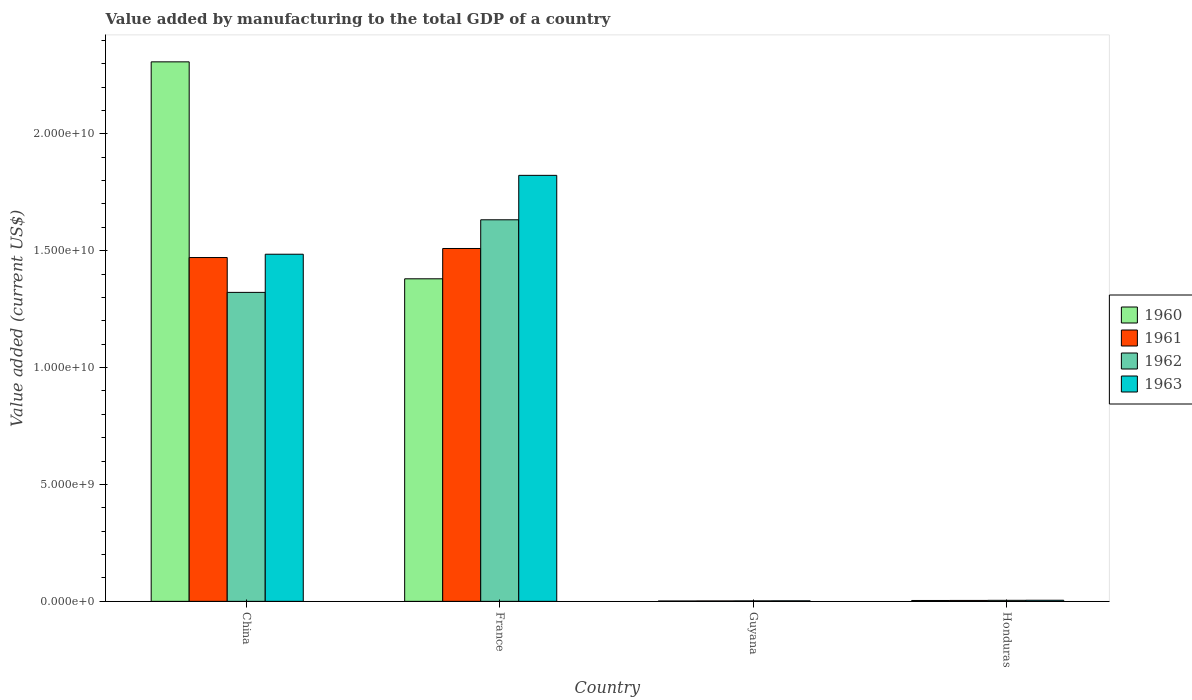How many different coloured bars are there?
Provide a succinct answer. 4. How many groups of bars are there?
Keep it short and to the point. 4. Are the number of bars per tick equal to the number of legend labels?
Your response must be concise. Yes. Are the number of bars on each tick of the X-axis equal?
Keep it short and to the point. Yes. What is the label of the 4th group of bars from the left?
Offer a very short reply. Honduras. What is the value added by manufacturing to the total GDP in 1960 in Honduras?
Your answer should be compact. 3.80e+07. Across all countries, what is the maximum value added by manufacturing to the total GDP in 1960?
Provide a short and direct response. 2.31e+1. Across all countries, what is the minimum value added by manufacturing to the total GDP in 1960?
Your answer should be very brief. 1.59e+07. In which country was the value added by manufacturing to the total GDP in 1962 minimum?
Offer a terse response. Guyana. What is the total value added by manufacturing to the total GDP in 1962 in the graph?
Your answer should be compact. 2.96e+1. What is the difference between the value added by manufacturing to the total GDP in 1961 in China and that in Honduras?
Provide a short and direct response. 1.47e+1. What is the difference between the value added by manufacturing to the total GDP in 1963 in Guyana and the value added by manufacturing to the total GDP in 1960 in China?
Offer a terse response. -2.31e+1. What is the average value added by manufacturing to the total GDP in 1960 per country?
Ensure brevity in your answer.  9.23e+09. What is the difference between the value added by manufacturing to the total GDP of/in 1963 and value added by manufacturing to the total GDP of/in 1961 in China?
Your answer should be compact. 1.42e+08. What is the ratio of the value added by manufacturing to the total GDP in 1961 in China to that in Honduras?
Offer a very short reply. 367.26. Is the difference between the value added by manufacturing to the total GDP in 1963 in France and Honduras greater than the difference between the value added by manufacturing to the total GDP in 1961 in France and Honduras?
Offer a very short reply. Yes. What is the difference between the highest and the second highest value added by manufacturing to the total GDP in 1961?
Offer a terse response. 1.47e+1. What is the difference between the highest and the lowest value added by manufacturing to the total GDP in 1961?
Offer a very short reply. 1.51e+1. What does the 4th bar from the left in France represents?
Keep it short and to the point. 1963. What does the 4th bar from the right in Honduras represents?
Give a very brief answer. 1960. How many bars are there?
Your answer should be very brief. 16. Are all the bars in the graph horizontal?
Provide a succinct answer. No. How many countries are there in the graph?
Provide a succinct answer. 4. Does the graph contain any zero values?
Your response must be concise. No. Does the graph contain grids?
Your answer should be compact. No. How many legend labels are there?
Offer a terse response. 4. How are the legend labels stacked?
Make the answer very short. Vertical. What is the title of the graph?
Provide a succinct answer. Value added by manufacturing to the total GDP of a country. What is the label or title of the Y-axis?
Keep it short and to the point. Value added (current US$). What is the Value added (current US$) in 1960 in China?
Provide a succinct answer. 2.31e+1. What is the Value added (current US$) in 1961 in China?
Make the answer very short. 1.47e+1. What is the Value added (current US$) of 1962 in China?
Offer a very short reply. 1.32e+1. What is the Value added (current US$) in 1963 in China?
Provide a succinct answer. 1.49e+1. What is the Value added (current US$) of 1960 in France?
Your answer should be very brief. 1.38e+1. What is the Value added (current US$) of 1961 in France?
Offer a very short reply. 1.51e+1. What is the Value added (current US$) of 1962 in France?
Keep it short and to the point. 1.63e+1. What is the Value added (current US$) of 1963 in France?
Your response must be concise. 1.82e+1. What is the Value added (current US$) of 1960 in Guyana?
Give a very brief answer. 1.59e+07. What is the Value added (current US$) in 1961 in Guyana?
Your answer should be compact. 1.84e+07. What is the Value added (current US$) of 1962 in Guyana?
Provide a short and direct response. 2.08e+07. What is the Value added (current US$) of 1963 in Guyana?
Make the answer very short. 2.32e+07. What is the Value added (current US$) of 1960 in Honduras?
Your answer should be compact. 3.80e+07. What is the Value added (current US$) in 1961 in Honduras?
Provide a short and direct response. 4.00e+07. What is the Value added (current US$) in 1962 in Honduras?
Your answer should be compact. 4.41e+07. What is the Value added (current US$) in 1963 in Honduras?
Offer a very short reply. 4.76e+07. Across all countries, what is the maximum Value added (current US$) in 1960?
Offer a terse response. 2.31e+1. Across all countries, what is the maximum Value added (current US$) in 1961?
Your answer should be very brief. 1.51e+1. Across all countries, what is the maximum Value added (current US$) of 1962?
Your response must be concise. 1.63e+1. Across all countries, what is the maximum Value added (current US$) in 1963?
Offer a very short reply. 1.82e+1. Across all countries, what is the minimum Value added (current US$) in 1960?
Your response must be concise. 1.59e+07. Across all countries, what is the minimum Value added (current US$) in 1961?
Make the answer very short. 1.84e+07. Across all countries, what is the minimum Value added (current US$) of 1962?
Ensure brevity in your answer.  2.08e+07. Across all countries, what is the minimum Value added (current US$) of 1963?
Your answer should be very brief. 2.32e+07. What is the total Value added (current US$) of 1960 in the graph?
Offer a terse response. 3.69e+1. What is the total Value added (current US$) of 1961 in the graph?
Your answer should be compact. 2.99e+1. What is the total Value added (current US$) of 1962 in the graph?
Your answer should be compact. 2.96e+1. What is the total Value added (current US$) of 1963 in the graph?
Ensure brevity in your answer.  3.31e+1. What is the difference between the Value added (current US$) in 1960 in China and that in France?
Offer a terse response. 9.28e+09. What is the difference between the Value added (current US$) in 1961 in China and that in France?
Keep it short and to the point. -3.87e+08. What is the difference between the Value added (current US$) in 1962 in China and that in France?
Your answer should be compact. -3.11e+09. What is the difference between the Value added (current US$) of 1963 in China and that in France?
Your answer should be compact. -3.37e+09. What is the difference between the Value added (current US$) of 1960 in China and that in Guyana?
Your answer should be very brief. 2.31e+1. What is the difference between the Value added (current US$) in 1961 in China and that in Guyana?
Your answer should be compact. 1.47e+1. What is the difference between the Value added (current US$) of 1962 in China and that in Guyana?
Offer a very short reply. 1.32e+1. What is the difference between the Value added (current US$) in 1963 in China and that in Guyana?
Offer a terse response. 1.48e+1. What is the difference between the Value added (current US$) of 1960 in China and that in Honduras?
Offer a terse response. 2.30e+1. What is the difference between the Value added (current US$) of 1961 in China and that in Honduras?
Provide a succinct answer. 1.47e+1. What is the difference between the Value added (current US$) of 1962 in China and that in Honduras?
Your response must be concise. 1.32e+1. What is the difference between the Value added (current US$) of 1963 in China and that in Honduras?
Keep it short and to the point. 1.48e+1. What is the difference between the Value added (current US$) of 1960 in France and that in Guyana?
Give a very brief answer. 1.38e+1. What is the difference between the Value added (current US$) in 1961 in France and that in Guyana?
Make the answer very short. 1.51e+1. What is the difference between the Value added (current US$) of 1962 in France and that in Guyana?
Offer a very short reply. 1.63e+1. What is the difference between the Value added (current US$) of 1963 in France and that in Guyana?
Give a very brief answer. 1.82e+1. What is the difference between the Value added (current US$) in 1960 in France and that in Honduras?
Ensure brevity in your answer.  1.38e+1. What is the difference between the Value added (current US$) in 1961 in France and that in Honduras?
Your answer should be compact. 1.51e+1. What is the difference between the Value added (current US$) of 1962 in France and that in Honduras?
Your answer should be compact. 1.63e+1. What is the difference between the Value added (current US$) in 1963 in France and that in Honduras?
Give a very brief answer. 1.82e+1. What is the difference between the Value added (current US$) in 1960 in Guyana and that in Honduras?
Provide a short and direct response. -2.22e+07. What is the difference between the Value added (current US$) in 1961 in Guyana and that in Honduras?
Your answer should be compact. -2.17e+07. What is the difference between the Value added (current US$) in 1962 in Guyana and that in Honduras?
Offer a very short reply. -2.33e+07. What is the difference between the Value added (current US$) of 1963 in Guyana and that in Honduras?
Provide a succinct answer. -2.44e+07. What is the difference between the Value added (current US$) in 1960 in China and the Value added (current US$) in 1961 in France?
Offer a terse response. 7.98e+09. What is the difference between the Value added (current US$) in 1960 in China and the Value added (current US$) in 1962 in France?
Your response must be concise. 6.76e+09. What is the difference between the Value added (current US$) of 1960 in China and the Value added (current US$) of 1963 in France?
Ensure brevity in your answer.  4.86e+09. What is the difference between the Value added (current US$) in 1961 in China and the Value added (current US$) in 1962 in France?
Provide a short and direct response. -1.61e+09. What is the difference between the Value added (current US$) of 1961 in China and the Value added (current US$) of 1963 in France?
Your answer should be very brief. -3.52e+09. What is the difference between the Value added (current US$) in 1962 in China and the Value added (current US$) in 1963 in France?
Your response must be concise. -5.01e+09. What is the difference between the Value added (current US$) of 1960 in China and the Value added (current US$) of 1961 in Guyana?
Your response must be concise. 2.31e+1. What is the difference between the Value added (current US$) in 1960 in China and the Value added (current US$) in 1962 in Guyana?
Provide a short and direct response. 2.31e+1. What is the difference between the Value added (current US$) of 1960 in China and the Value added (current US$) of 1963 in Guyana?
Offer a terse response. 2.31e+1. What is the difference between the Value added (current US$) of 1961 in China and the Value added (current US$) of 1962 in Guyana?
Your answer should be very brief. 1.47e+1. What is the difference between the Value added (current US$) of 1961 in China and the Value added (current US$) of 1963 in Guyana?
Keep it short and to the point. 1.47e+1. What is the difference between the Value added (current US$) of 1962 in China and the Value added (current US$) of 1963 in Guyana?
Give a very brief answer. 1.32e+1. What is the difference between the Value added (current US$) of 1960 in China and the Value added (current US$) of 1961 in Honduras?
Offer a terse response. 2.30e+1. What is the difference between the Value added (current US$) of 1960 in China and the Value added (current US$) of 1962 in Honduras?
Your response must be concise. 2.30e+1. What is the difference between the Value added (current US$) in 1960 in China and the Value added (current US$) in 1963 in Honduras?
Provide a succinct answer. 2.30e+1. What is the difference between the Value added (current US$) of 1961 in China and the Value added (current US$) of 1962 in Honduras?
Provide a short and direct response. 1.47e+1. What is the difference between the Value added (current US$) in 1961 in China and the Value added (current US$) in 1963 in Honduras?
Give a very brief answer. 1.47e+1. What is the difference between the Value added (current US$) in 1962 in China and the Value added (current US$) in 1963 in Honduras?
Give a very brief answer. 1.32e+1. What is the difference between the Value added (current US$) of 1960 in France and the Value added (current US$) of 1961 in Guyana?
Give a very brief answer. 1.38e+1. What is the difference between the Value added (current US$) in 1960 in France and the Value added (current US$) in 1962 in Guyana?
Keep it short and to the point. 1.38e+1. What is the difference between the Value added (current US$) in 1960 in France and the Value added (current US$) in 1963 in Guyana?
Your response must be concise. 1.38e+1. What is the difference between the Value added (current US$) of 1961 in France and the Value added (current US$) of 1962 in Guyana?
Provide a short and direct response. 1.51e+1. What is the difference between the Value added (current US$) in 1961 in France and the Value added (current US$) in 1963 in Guyana?
Your response must be concise. 1.51e+1. What is the difference between the Value added (current US$) in 1962 in France and the Value added (current US$) in 1963 in Guyana?
Make the answer very short. 1.63e+1. What is the difference between the Value added (current US$) in 1960 in France and the Value added (current US$) in 1961 in Honduras?
Your answer should be very brief. 1.38e+1. What is the difference between the Value added (current US$) in 1960 in France and the Value added (current US$) in 1962 in Honduras?
Provide a succinct answer. 1.38e+1. What is the difference between the Value added (current US$) in 1960 in France and the Value added (current US$) in 1963 in Honduras?
Offer a terse response. 1.38e+1. What is the difference between the Value added (current US$) of 1961 in France and the Value added (current US$) of 1962 in Honduras?
Your answer should be very brief. 1.51e+1. What is the difference between the Value added (current US$) of 1961 in France and the Value added (current US$) of 1963 in Honduras?
Your answer should be compact. 1.50e+1. What is the difference between the Value added (current US$) of 1962 in France and the Value added (current US$) of 1963 in Honduras?
Provide a short and direct response. 1.63e+1. What is the difference between the Value added (current US$) of 1960 in Guyana and the Value added (current US$) of 1961 in Honduras?
Make the answer very short. -2.42e+07. What is the difference between the Value added (current US$) of 1960 in Guyana and the Value added (current US$) of 1962 in Honduras?
Give a very brief answer. -2.82e+07. What is the difference between the Value added (current US$) in 1960 in Guyana and the Value added (current US$) in 1963 in Honduras?
Give a very brief answer. -3.17e+07. What is the difference between the Value added (current US$) of 1961 in Guyana and the Value added (current US$) of 1962 in Honduras?
Your answer should be compact. -2.57e+07. What is the difference between the Value added (current US$) of 1961 in Guyana and the Value added (current US$) of 1963 in Honduras?
Your answer should be compact. -2.92e+07. What is the difference between the Value added (current US$) of 1962 in Guyana and the Value added (current US$) of 1963 in Honduras?
Provide a short and direct response. -2.68e+07. What is the average Value added (current US$) of 1960 per country?
Your answer should be compact. 9.23e+09. What is the average Value added (current US$) of 1961 per country?
Your answer should be very brief. 7.47e+09. What is the average Value added (current US$) of 1962 per country?
Offer a very short reply. 7.40e+09. What is the average Value added (current US$) in 1963 per country?
Keep it short and to the point. 8.29e+09. What is the difference between the Value added (current US$) in 1960 and Value added (current US$) in 1961 in China?
Give a very brief answer. 8.37e+09. What is the difference between the Value added (current US$) of 1960 and Value added (current US$) of 1962 in China?
Your response must be concise. 9.86e+09. What is the difference between the Value added (current US$) in 1960 and Value added (current US$) in 1963 in China?
Provide a succinct answer. 8.23e+09. What is the difference between the Value added (current US$) of 1961 and Value added (current US$) of 1962 in China?
Ensure brevity in your answer.  1.49e+09. What is the difference between the Value added (current US$) of 1961 and Value added (current US$) of 1963 in China?
Make the answer very short. -1.42e+08. What is the difference between the Value added (current US$) of 1962 and Value added (current US$) of 1963 in China?
Your response must be concise. -1.63e+09. What is the difference between the Value added (current US$) of 1960 and Value added (current US$) of 1961 in France?
Ensure brevity in your answer.  -1.30e+09. What is the difference between the Value added (current US$) in 1960 and Value added (current US$) in 1962 in France?
Offer a very short reply. -2.52e+09. What is the difference between the Value added (current US$) of 1960 and Value added (current US$) of 1963 in France?
Your answer should be very brief. -4.43e+09. What is the difference between the Value added (current US$) of 1961 and Value added (current US$) of 1962 in France?
Your response must be concise. -1.23e+09. What is the difference between the Value added (current US$) of 1961 and Value added (current US$) of 1963 in France?
Provide a succinct answer. -3.13e+09. What is the difference between the Value added (current US$) of 1962 and Value added (current US$) of 1963 in France?
Give a very brief answer. -1.90e+09. What is the difference between the Value added (current US$) in 1960 and Value added (current US$) in 1961 in Guyana?
Make the answer very short. -2.51e+06. What is the difference between the Value added (current US$) in 1960 and Value added (current US$) in 1962 in Guyana?
Give a very brief answer. -4.90e+06. What is the difference between the Value added (current US$) of 1960 and Value added (current US$) of 1963 in Guyana?
Ensure brevity in your answer.  -7.29e+06. What is the difference between the Value added (current US$) of 1961 and Value added (current US$) of 1962 in Guyana?
Offer a terse response. -2.39e+06. What is the difference between the Value added (current US$) in 1961 and Value added (current US$) in 1963 in Guyana?
Provide a short and direct response. -4.78e+06. What is the difference between the Value added (current US$) in 1962 and Value added (current US$) in 1963 in Guyana?
Provide a short and direct response. -2.39e+06. What is the difference between the Value added (current US$) of 1960 and Value added (current US$) of 1962 in Honduras?
Provide a short and direct response. -6.05e+06. What is the difference between the Value added (current US$) of 1960 and Value added (current US$) of 1963 in Honduras?
Give a very brief answer. -9.50e+06. What is the difference between the Value added (current US$) in 1961 and Value added (current US$) in 1962 in Honduras?
Provide a short and direct response. -4.05e+06. What is the difference between the Value added (current US$) of 1961 and Value added (current US$) of 1963 in Honduras?
Your response must be concise. -7.50e+06. What is the difference between the Value added (current US$) in 1962 and Value added (current US$) in 1963 in Honduras?
Provide a succinct answer. -3.45e+06. What is the ratio of the Value added (current US$) in 1960 in China to that in France?
Your answer should be very brief. 1.67. What is the ratio of the Value added (current US$) in 1961 in China to that in France?
Offer a terse response. 0.97. What is the ratio of the Value added (current US$) in 1962 in China to that in France?
Give a very brief answer. 0.81. What is the ratio of the Value added (current US$) of 1963 in China to that in France?
Keep it short and to the point. 0.81. What is the ratio of the Value added (current US$) in 1960 in China to that in Guyana?
Your answer should be very brief. 1454.66. What is the ratio of the Value added (current US$) in 1961 in China to that in Guyana?
Offer a very short reply. 800.48. What is the ratio of the Value added (current US$) in 1962 in China to that in Guyana?
Give a very brief answer. 636.5. What is the ratio of the Value added (current US$) of 1963 in China to that in Guyana?
Provide a short and direct response. 641.28. What is the ratio of the Value added (current US$) of 1960 in China to that in Honduras?
Give a very brief answer. 606.59. What is the ratio of the Value added (current US$) in 1961 in China to that in Honduras?
Provide a succinct answer. 367.26. What is the ratio of the Value added (current US$) in 1962 in China to that in Honduras?
Offer a very short reply. 299.73. What is the ratio of the Value added (current US$) of 1963 in China to that in Honduras?
Your answer should be compact. 312.32. What is the ratio of the Value added (current US$) in 1960 in France to that in Guyana?
Give a very brief answer. 869.7. What is the ratio of the Value added (current US$) of 1961 in France to that in Guyana?
Your answer should be very brief. 821.55. What is the ratio of the Value added (current US$) of 1962 in France to that in Guyana?
Keep it short and to the point. 786.05. What is the ratio of the Value added (current US$) in 1963 in France to that in Guyana?
Keep it short and to the point. 786.97. What is the ratio of the Value added (current US$) of 1960 in France to that in Honduras?
Provide a succinct answer. 362.66. What is the ratio of the Value added (current US$) in 1961 in France to that in Honduras?
Give a very brief answer. 376.93. What is the ratio of the Value added (current US$) in 1962 in France to that in Honduras?
Your answer should be very brief. 370.15. What is the ratio of the Value added (current US$) in 1963 in France to that in Honduras?
Ensure brevity in your answer.  383.28. What is the ratio of the Value added (current US$) of 1960 in Guyana to that in Honduras?
Your answer should be compact. 0.42. What is the ratio of the Value added (current US$) in 1961 in Guyana to that in Honduras?
Your answer should be very brief. 0.46. What is the ratio of the Value added (current US$) in 1962 in Guyana to that in Honduras?
Keep it short and to the point. 0.47. What is the ratio of the Value added (current US$) in 1963 in Guyana to that in Honduras?
Provide a succinct answer. 0.49. What is the difference between the highest and the second highest Value added (current US$) in 1960?
Your answer should be very brief. 9.28e+09. What is the difference between the highest and the second highest Value added (current US$) in 1961?
Make the answer very short. 3.87e+08. What is the difference between the highest and the second highest Value added (current US$) in 1962?
Give a very brief answer. 3.11e+09. What is the difference between the highest and the second highest Value added (current US$) in 1963?
Your answer should be compact. 3.37e+09. What is the difference between the highest and the lowest Value added (current US$) of 1960?
Your answer should be compact. 2.31e+1. What is the difference between the highest and the lowest Value added (current US$) of 1961?
Keep it short and to the point. 1.51e+1. What is the difference between the highest and the lowest Value added (current US$) of 1962?
Provide a succinct answer. 1.63e+1. What is the difference between the highest and the lowest Value added (current US$) of 1963?
Offer a very short reply. 1.82e+1. 